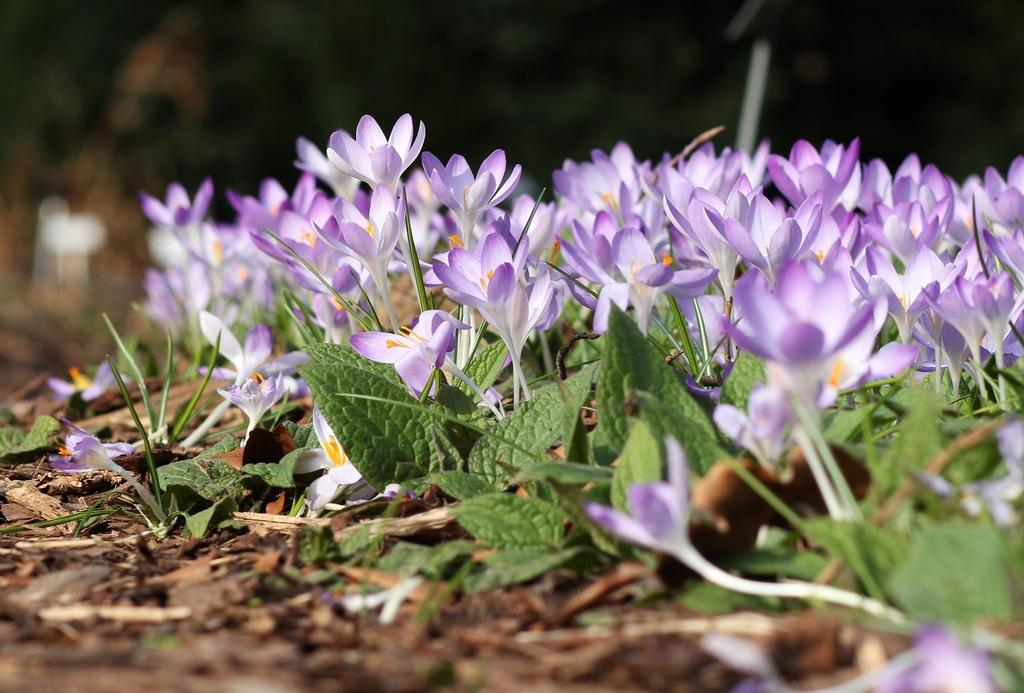What type of plant life can be seen in the image? There are flowers and leaves in the image. Where are the flowers and leaves located? The flowers and leaves are on the ground in the image. What country is mentioned in the image? There is no country mentioned in the image; it only features flowers and leaves on the ground. What type of reading material is visible in the image? There is no reading material present in the image; it only features flowers and leaves on the ground. 